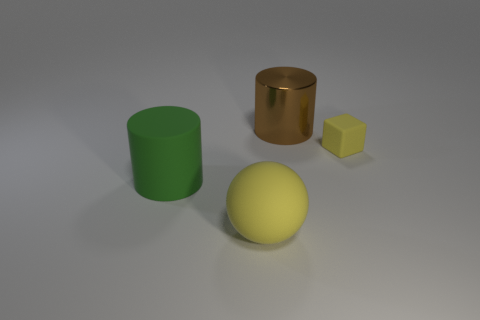Are there any large green cylinders that are to the right of the yellow rubber object in front of the tiny rubber thing?
Your answer should be very brief. No. Are there the same number of big metal things on the right side of the small thing and tiny yellow matte things?
Your answer should be very brief. No. What number of other objects are the same size as the matte cylinder?
Provide a short and direct response. 2. Does the large thing behind the tiny yellow thing have the same material as the cylinder that is on the left side of the large brown object?
Your answer should be compact. No. What is the size of the yellow thing that is behind the large cylinder that is in front of the small cube?
Your answer should be very brief. Small. Is there a matte block of the same color as the large metallic cylinder?
Offer a very short reply. No. There is a big cylinder in front of the tiny rubber object; does it have the same color as the rubber object to the right of the brown cylinder?
Make the answer very short. No. The metallic thing has what shape?
Your response must be concise. Cylinder. How many large matte cylinders are to the left of the large sphere?
Your answer should be very brief. 1. What number of tiny yellow things are the same material as the yellow ball?
Ensure brevity in your answer.  1. 